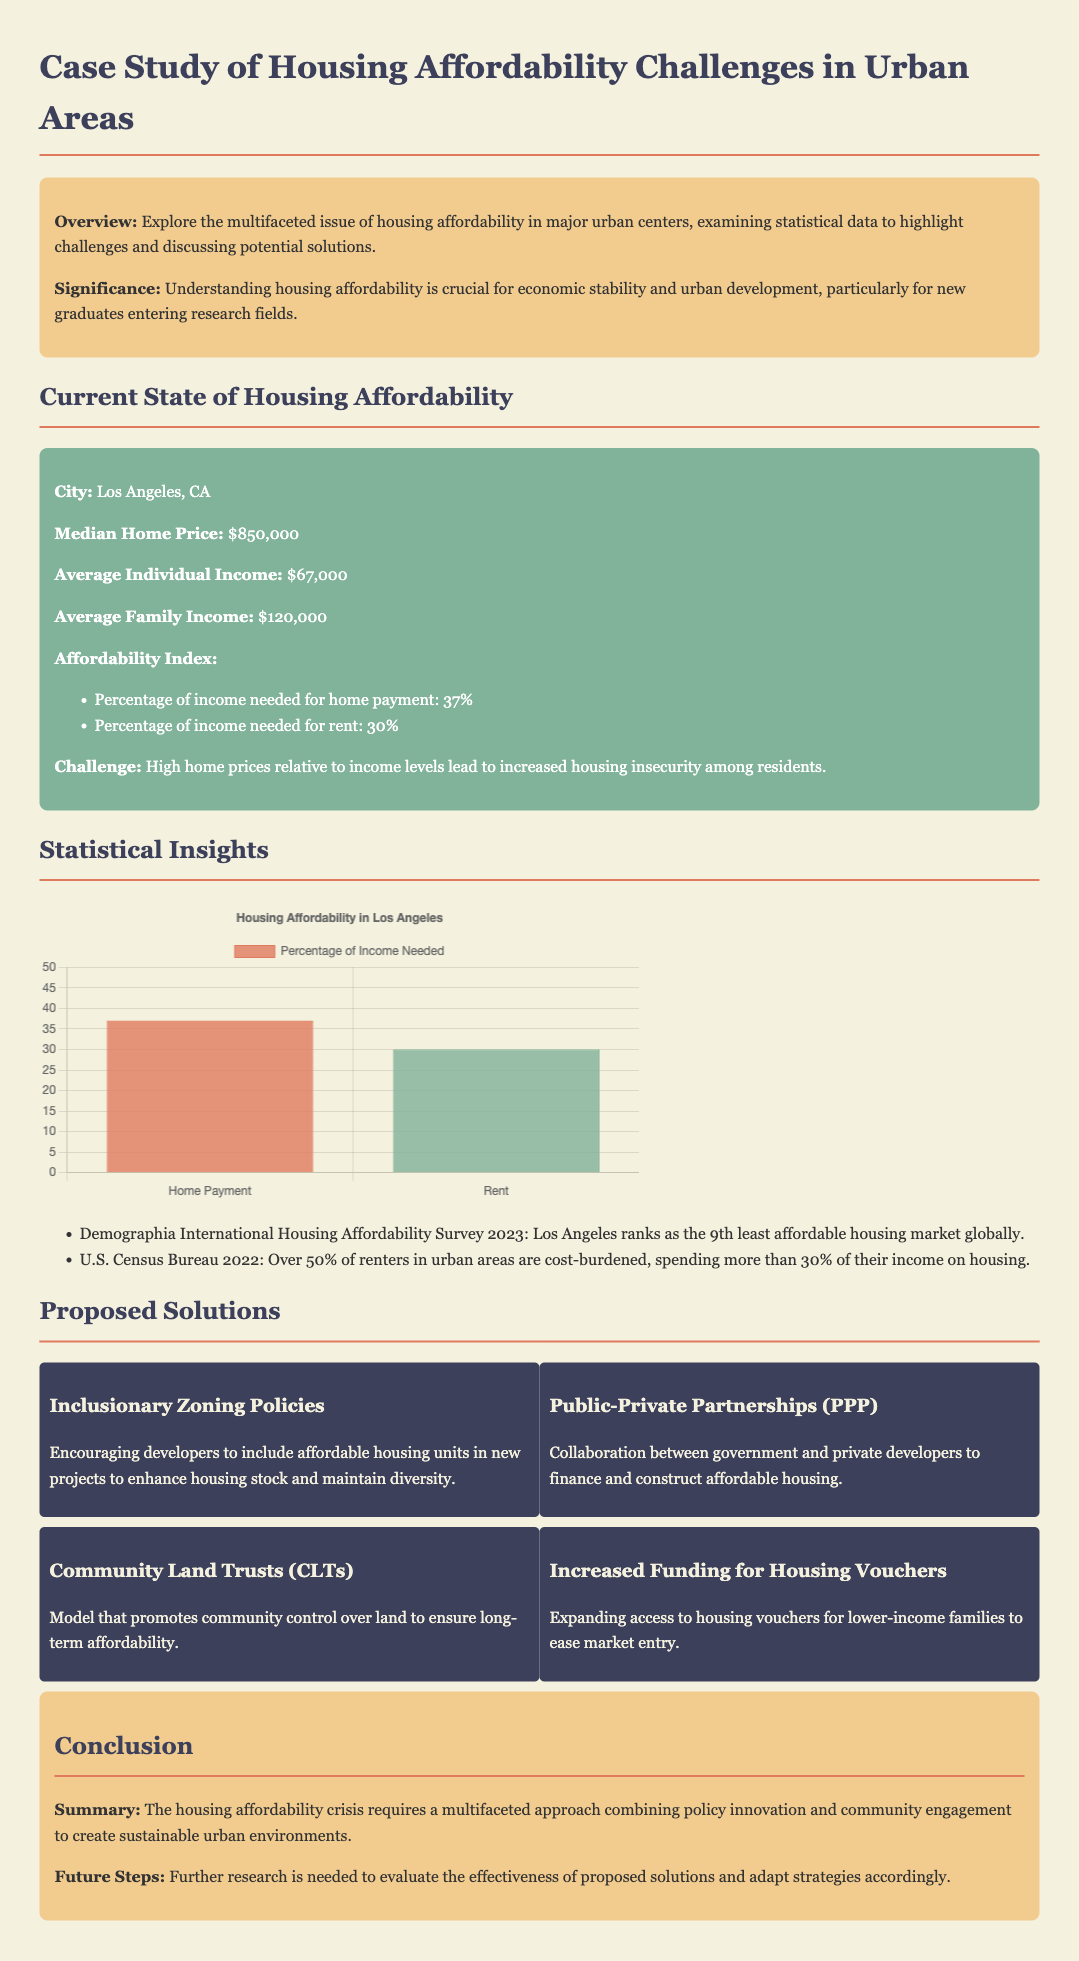What is the median home price in Los Angeles? The median home price is stated as $850,000 in the document.
Answer: $850,000 What percentage of individual income is needed for home payment? The document indicates that 37% of an individual's income is required for home payment.
Answer: 37% What is the average family income listed? The document mentions that the average family income is $120,000.
Answer: $120,000 Which housing market ranks as the 9th least affordable globally? The document specifies that Los Angeles ranks as the 9th least affordable housing market globally according to the Demographia International Housing Affordability Survey 2023.
Answer: Los Angeles What policy encourages developers to include affordable housing units? The document outlines that inclusionary zoning policies encourage developers to include affordable housing units.
Answer: Inclusionary Zoning Policies What is a proposed solution that emphasizes community control? The proposed solution focusing on community control mentioned in the document is Community Land Trusts (CLTs).
Answer: Community Land Trusts What percentage of renters in urban areas are cost-burdened? The document states that over 50% of renters in urban areas are cost-burdened according to the U.S. Census Bureau 2022.
Answer: Over 50% What is the significance of understanding housing affordability? The document emphasizes that understanding housing affordability is crucial for economic stability and urban development.
Answer: Economic stability and urban development What is suggested as a future step for addressing housing affordability challenges? The document suggests that further research is needed to evaluate the effectiveness of proposed solutions.
Answer: Further research 